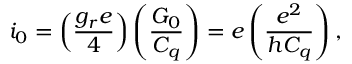Convert formula to latex. <formula><loc_0><loc_0><loc_500><loc_500>i _ { 0 } = \left ( \frac { g _ { r } e } { 4 } \right ) \left ( \frac { G _ { 0 } } { C _ { q } } \right ) = e \left ( \frac { e ^ { 2 } } { h C _ { q } } \right ) ,</formula> 